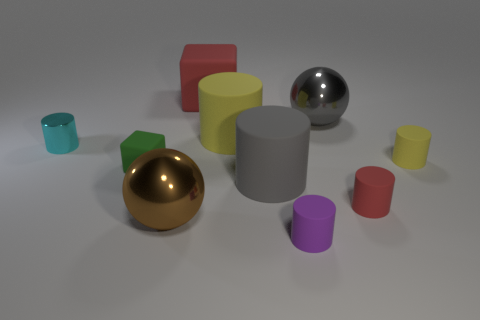What color is the other matte cylinder that is the same size as the gray cylinder?
Provide a succinct answer. Yellow. What number of tiny objects are both left of the brown object and in front of the small metal object?
Keep it short and to the point. 1. What material is the small purple thing?
Keep it short and to the point. Rubber. What number of objects are tiny brown cylinders or brown metallic spheres?
Make the answer very short. 1. Does the cylinder that is on the left side of the big matte cube have the same size as the yellow rubber cylinder left of the tiny purple object?
Keep it short and to the point. No. How many other things are there of the same size as the gray metal thing?
Keep it short and to the point. 4. How many objects are either small red rubber things that are to the right of the gray ball or cylinders that are right of the tiny cyan shiny cylinder?
Your response must be concise. 5. Is the brown object made of the same material as the large gray ball on the right side of the big yellow cylinder?
Provide a short and direct response. Yes. What number of other objects are there of the same shape as the large gray matte object?
Provide a succinct answer. 5. What is the red thing that is in front of the yellow rubber object left of the sphere that is behind the tiny green rubber object made of?
Your answer should be compact. Rubber. 